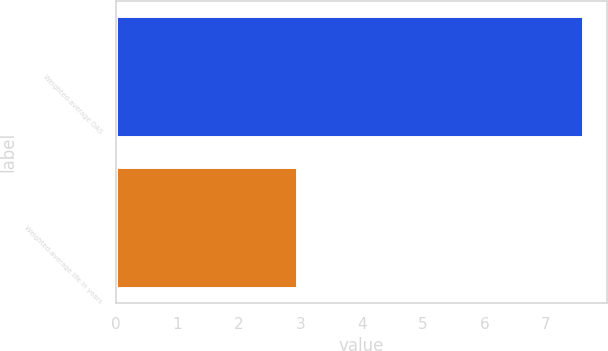Convert chart. <chart><loc_0><loc_0><loc_500><loc_500><bar_chart><fcel>Weighted-average OAS<fcel>Weighted-average life in years<nl><fcel>7.61<fcel>2.95<nl></chart> 